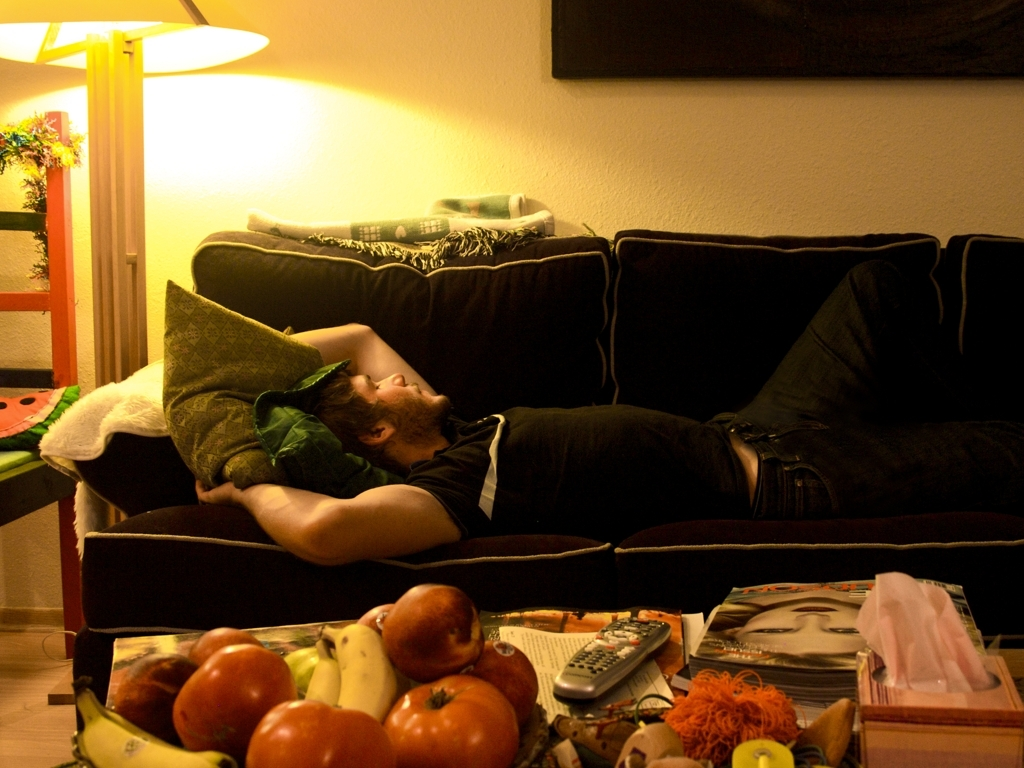Which objects on the table stand out the most and why? The brightly colored fruits on the table are the most eye-catching objects due to their vibrant colors and relatively large quantity, creating a focal point on the table. Judging by the items on the table, what kind of person might live here? The person might have an inclination towards a healthy lifestyle, evidenced by the fresh fruits. Moreover, the variety of magazines and remote controls suggest a person who enjoys leisure time with both reading and perhaps watching television. 